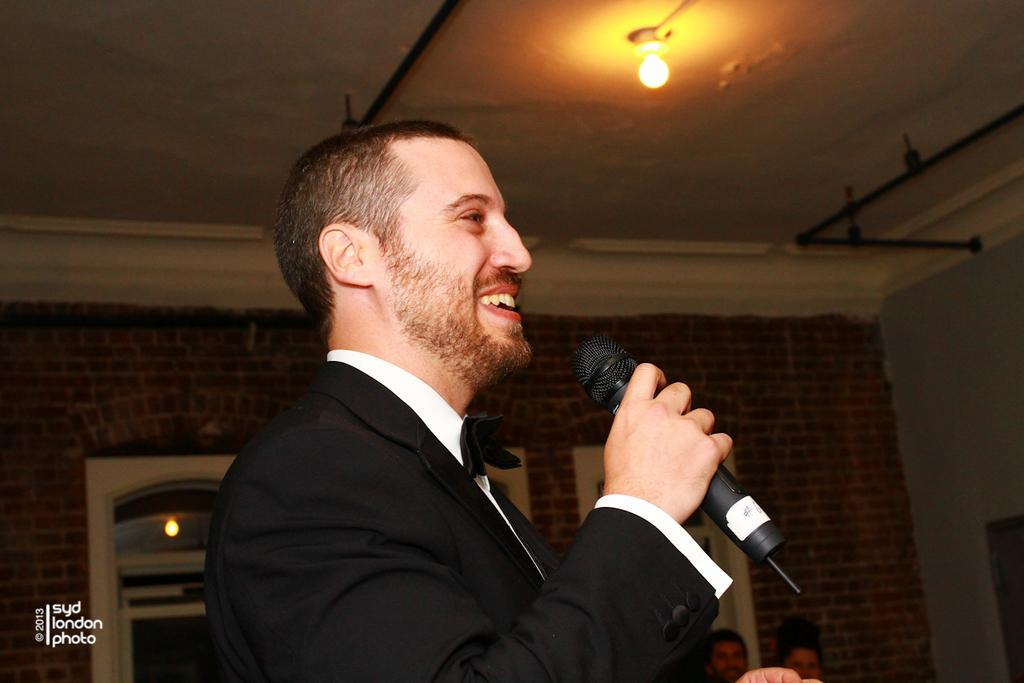What is the main subject of the image? There is a man in the image. What is the man doing in the image? The man is standing and speaking in the image. What is the man holding in the image? The man is holding a microphone in the image. What can be seen in the background of the image? There is a door and a light attached to the wall in the background of the image. What type of songs can be heard coming from the library in the image? There is no library present in the image, and therefore no songs can be heard coming from it. 